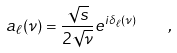<formula> <loc_0><loc_0><loc_500><loc_500>a _ { \ell } ( \nu ) = \frac { \sqrt { s } } { 2 \sqrt { \nu } } e ^ { i \delta _ { \ell } ( \nu ) } \quad ,</formula> 